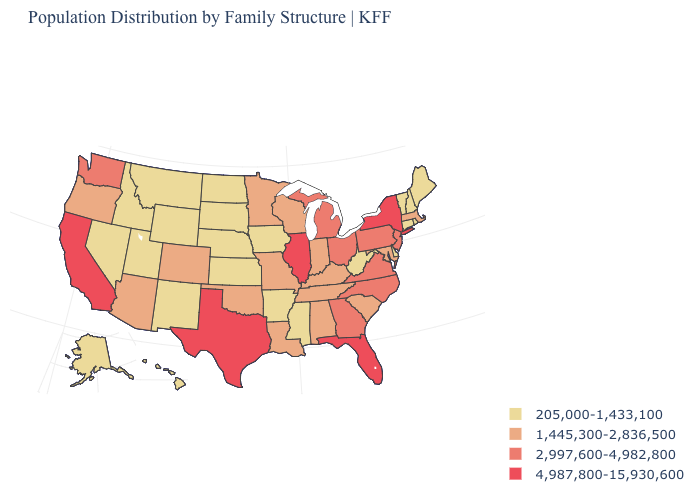Does Delaware have the same value as Florida?
Write a very short answer. No. Among the states that border Connecticut , does Rhode Island have the lowest value?
Give a very brief answer. Yes. What is the lowest value in the West?
Give a very brief answer. 205,000-1,433,100. Does California have a higher value than South Carolina?
Answer briefly. Yes. What is the value of Arizona?
Concise answer only. 1,445,300-2,836,500. Name the states that have a value in the range 1,445,300-2,836,500?
Be succinct. Alabama, Arizona, Colorado, Indiana, Kentucky, Louisiana, Maryland, Massachusetts, Minnesota, Missouri, Oklahoma, Oregon, South Carolina, Tennessee, Wisconsin. What is the highest value in the MidWest ?
Short answer required. 4,987,800-15,930,600. What is the value of New Hampshire?
Short answer required. 205,000-1,433,100. Which states have the lowest value in the West?
Be succinct. Alaska, Hawaii, Idaho, Montana, Nevada, New Mexico, Utah, Wyoming. Name the states that have a value in the range 4,987,800-15,930,600?
Write a very short answer. California, Florida, Illinois, New York, Texas. Does Nevada have the lowest value in the USA?
Concise answer only. Yes. Name the states that have a value in the range 1,445,300-2,836,500?
Write a very short answer. Alabama, Arizona, Colorado, Indiana, Kentucky, Louisiana, Maryland, Massachusetts, Minnesota, Missouri, Oklahoma, Oregon, South Carolina, Tennessee, Wisconsin. Name the states that have a value in the range 4,987,800-15,930,600?
Short answer required. California, Florida, Illinois, New York, Texas. What is the highest value in the USA?
Short answer required. 4,987,800-15,930,600. Does the map have missing data?
Be succinct. No. 